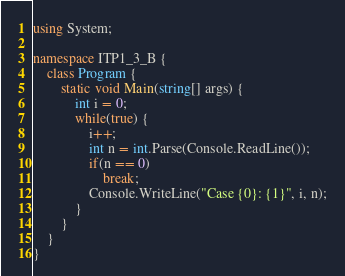Convert code to text. <code><loc_0><loc_0><loc_500><loc_500><_C#_>using System;

namespace ITP1_3_B {
    class Program {
        static void Main(string[] args) {
            int i = 0;
            while(true) {
                i++;
                int n = int.Parse(Console.ReadLine());
                if(n == 0)
                    break;
                Console.WriteLine("Case {0}: {1}", i, n);
            }
        }
    }
}</code> 